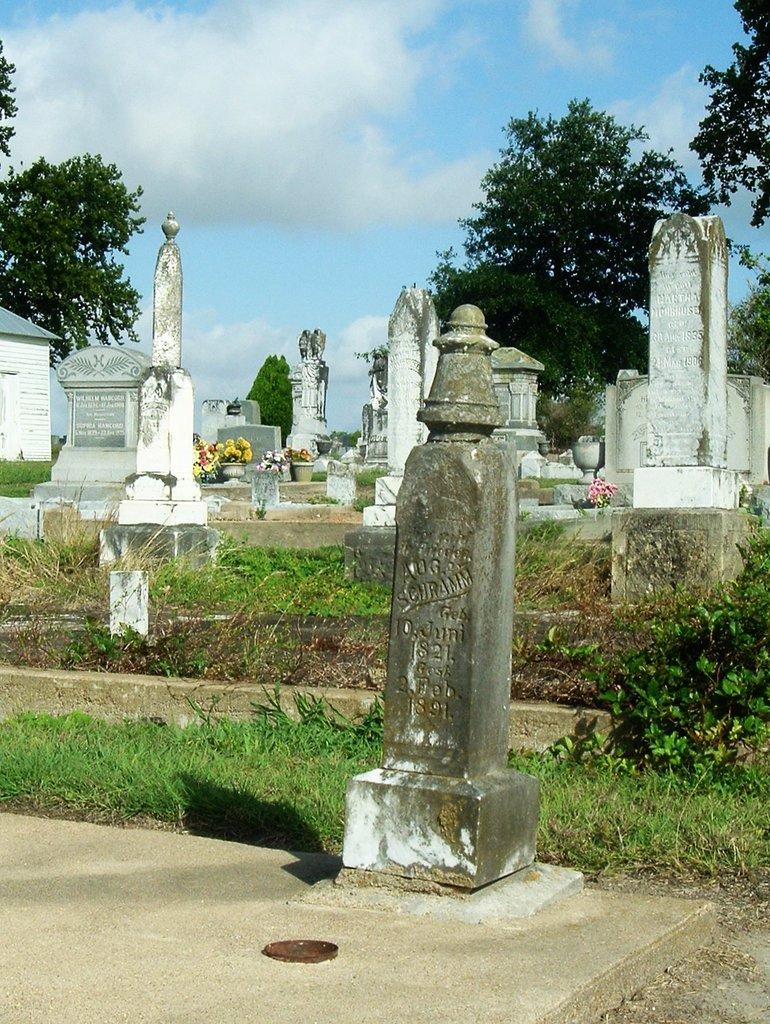What is the main subject in the middle of the image? There are gravestones in the middle of the image. What type of vegetation can be seen in the image? There are parts of grass visible in the image. What can be seen in the background of the image? There are trees and the sky visible in the background of the image. What is the condition of the sky in the image? Clouds are present in the sky. What type of pet is sitting on the tail of the achiever in the image? There is no pet or achiever present in the image; it features gravestones, grass, trees, and a cloudy sky. 